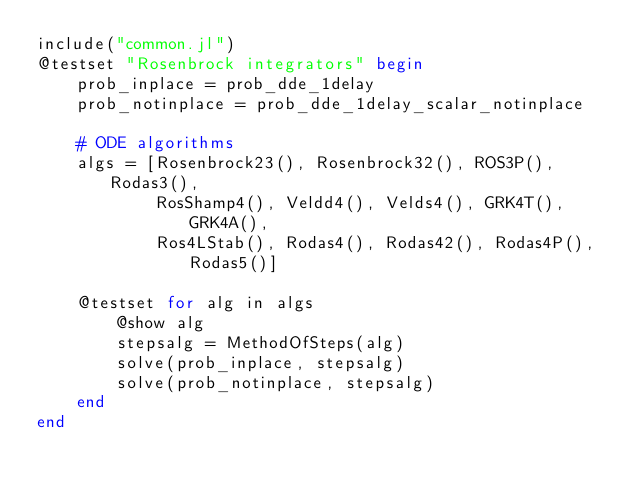Convert code to text. <code><loc_0><loc_0><loc_500><loc_500><_Julia_>include("common.jl")
@testset "Rosenbrock integrators" begin
    prob_inplace = prob_dde_1delay
    prob_notinplace = prob_dde_1delay_scalar_notinplace

    # ODE algorithms
    algs = [Rosenbrock23(), Rosenbrock32(), ROS3P(), Rodas3(),
            RosShamp4(), Veldd4(), Velds4(), GRK4T(), GRK4A(),
            Ros4LStab(), Rodas4(), Rodas42(), Rodas4P(), Rodas5()]

    @testset for alg in algs
        @show alg
        stepsalg = MethodOfSteps(alg)
        solve(prob_inplace, stepsalg)
        solve(prob_notinplace, stepsalg)
    end
end
</code> 